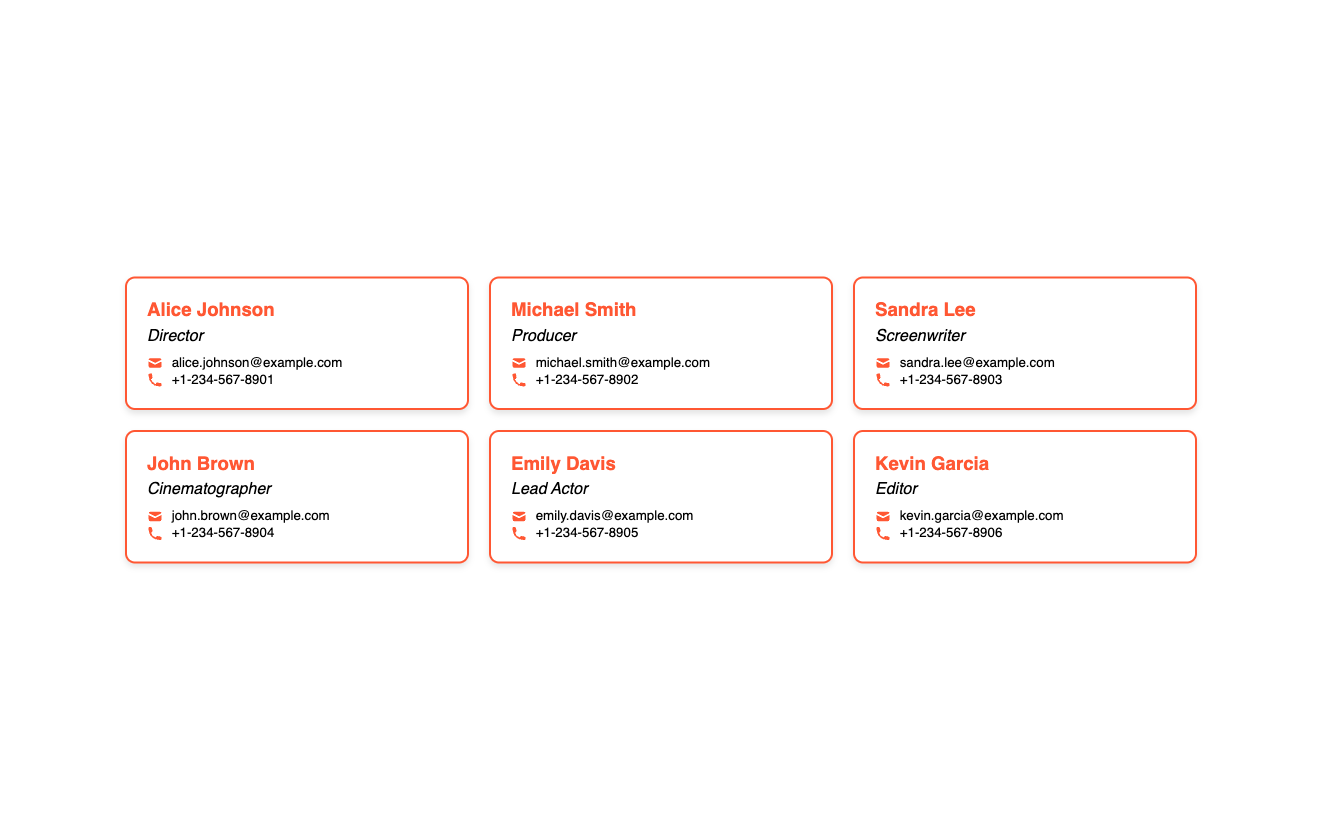What is the name of the director? The director's name is explicitly stated in the document as Alice Johnson.
Answer: Alice Johnson What role does Michael Smith have? The document specifies Michael Smith's role as Producer.
Answer: Producer How many primary contacts are listed in the document? By counting the cards, it's clear that there are eight primary contacts mentioned.
Answer: 8 What is Emily Davis's email address? The email address provided for Emily Davis can be found in the contact section of her card.
Answer: emily.davis@example.com Which contact has the phone number +1-234-567-8903? The card containing +1-234-567-8903 corresponds to Sandra Lee's contact information.
Answer: Sandra Lee Which role is associated with Kevin Garcia? The document clearly identifies Kevin Garcia's role as Editor.
Answer: Editor Which contact's name starts with 'J'? The first contact whose name begins with 'J' is John Brown, as seen in the document.
Answer: John Brown What color is used for the contact cards' border? The border color for the cards is explicitly mentioned as #FF5733.
Answer: #FF5733 